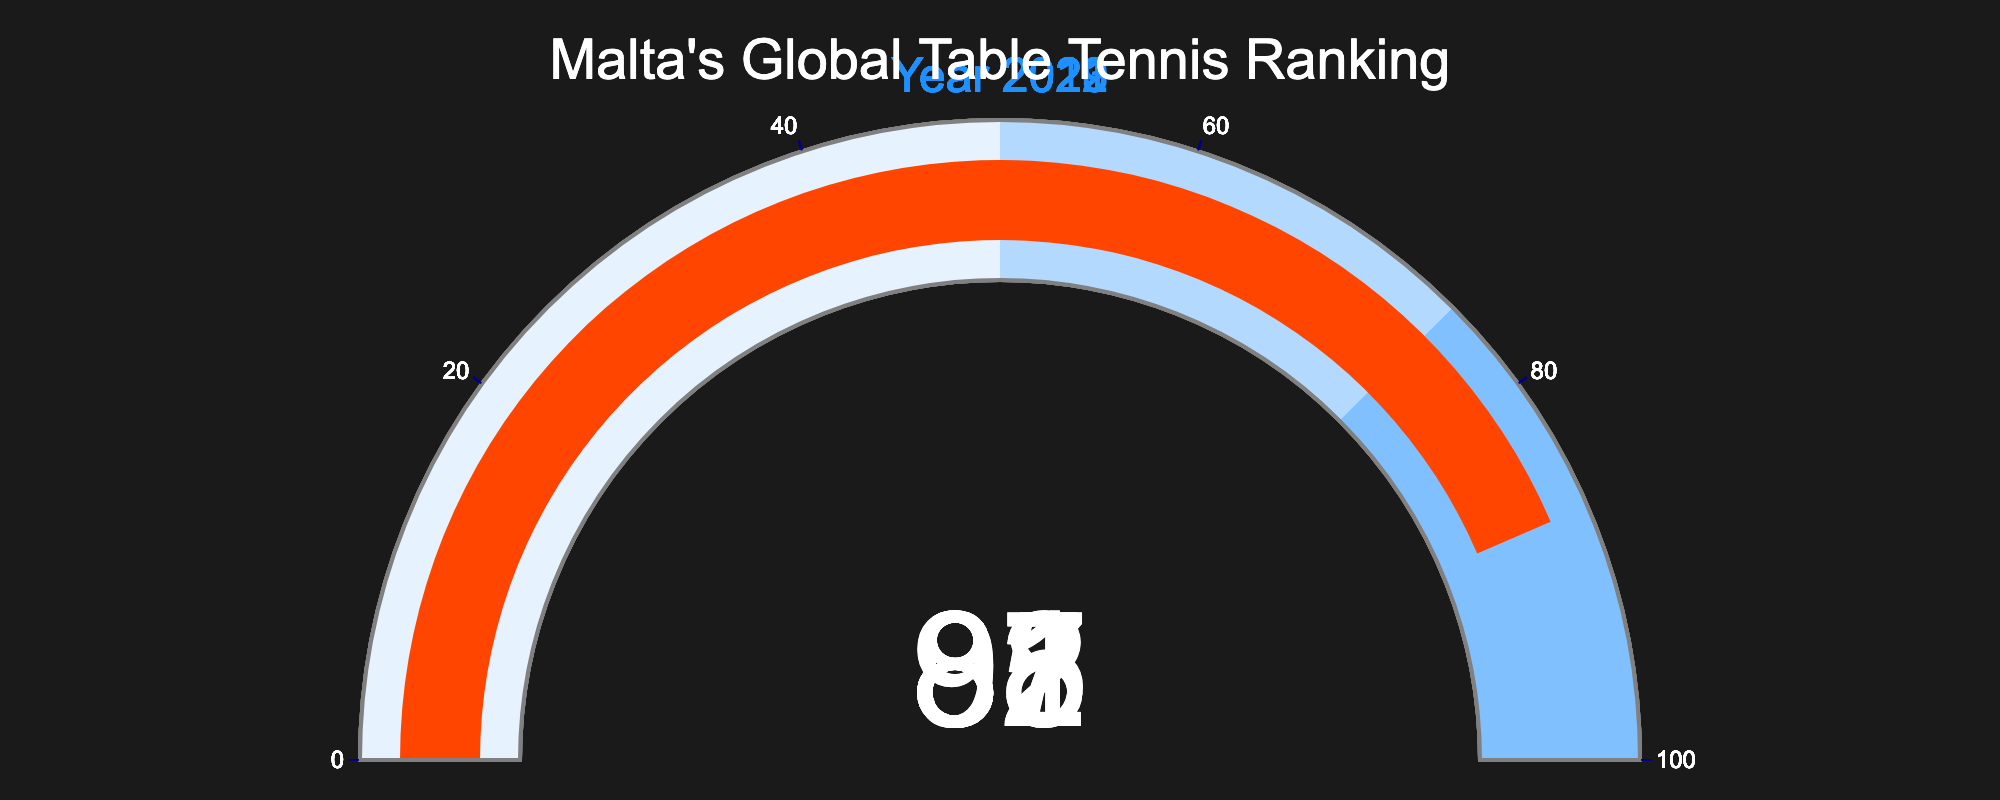what is the highest global ranking shown in the figure? The highest global ranking can be found by identifying the smallest value on the gauges. Here, it's the value 82 for the year 2023.
Answer: 82 which year shows the lowest global ranking? The lowest ranking is the highest number in the list. Here, it's 91 for the year 2020.
Answer: 2020 what is the range of values displayed on the gauges? The range of values is the difference between the highest and lowest numbers shown. Here, it's 91 - 82 = 9.
Answer: 9 how does the ranking in 2022 compare to 2019? By looking at the values, the ranking in 2022 (85) is better than in 2019 (87), as a lower ranking number indicates a better performance.
Answer: better what colors are used to represent different ranking ranges? The color on the gauges indicates three ranges: a lighter blue up to 50, a medium blue to 75, and a darker blue to 100. This means the ranges are 0-50, 50-75, and 75-100 respectively.
Answer: light blue, medium blue, dark blue has Malta's ranking improved or declined from 2021 to 2023? By comparing the values in the gauge charts, the ranking improves if the value decreases. In 2021, the ranking was 88 and it improved to 82 by 2023.
Answer: improved what is the average global ranking over the years shown? To find the average, sum the rankings of all years and divide by the number of years: (82 + 85 + 88 + 91 + 87) / 5 = 86.6.
Answer: 86.6 which years fall into the darkest blue range on the gauge chart? The darkest blue range covers the values from 75 to 100. All the years on the gauges have a range between 82 and 91. Therefore, all five years fall into this range.
Answer: 2019-2023 